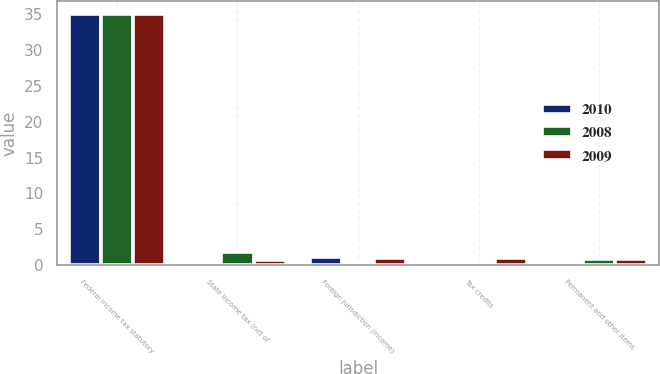Convert chart. <chart><loc_0><loc_0><loc_500><loc_500><stacked_bar_chart><ecel><fcel>Federal income tax statutory<fcel>State income tax (net of<fcel>Foreign jurisdiction (income)<fcel>Tax credits<fcel>Permanent and other items<nl><fcel>2010<fcel>35<fcel>0.5<fcel>1.2<fcel>0.2<fcel>0.3<nl><fcel>2008<fcel>35<fcel>1.9<fcel>0.4<fcel>0.2<fcel>0.9<nl><fcel>2009<fcel>35<fcel>0.8<fcel>1<fcel>1<fcel>0.9<nl></chart> 